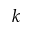<formula> <loc_0><loc_0><loc_500><loc_500>k</formula> 